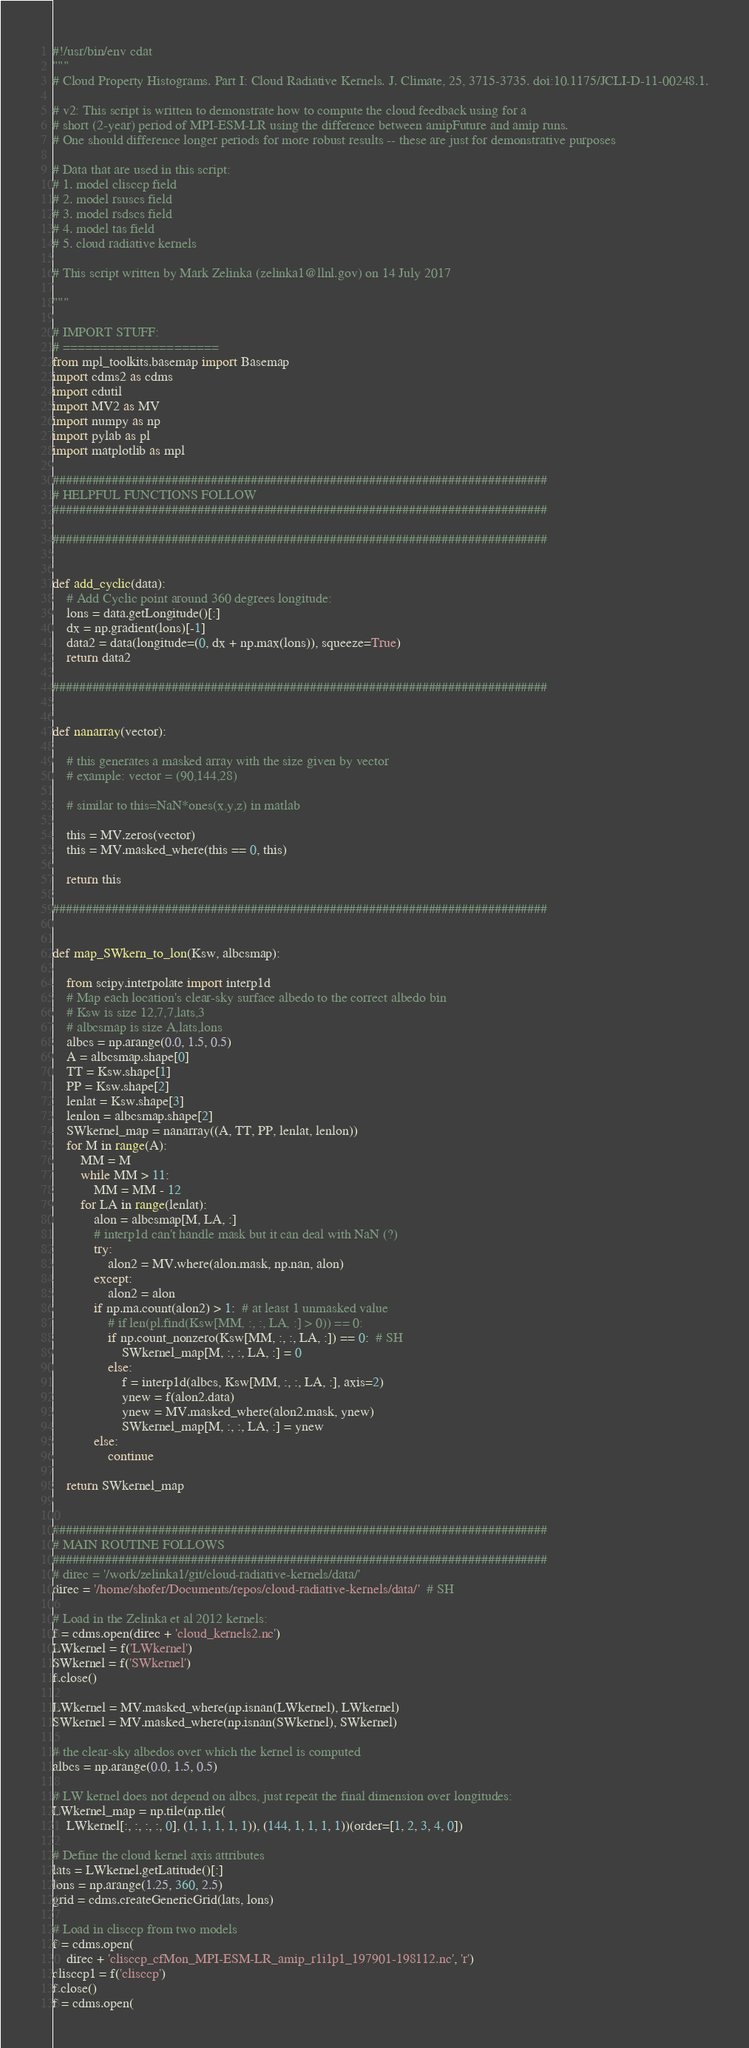<code> <loc_0><loc_0><loc_500><loc_500><_Python_>#!/usr/bin/env cdat
"""
# Cloud Property Histograms. Part I: Cloud Radiative Kernels. J. Climate, 25, 3715-3735. doi:10.1175/JCLI-D-11-00248.1.

# v2: This script is written to demonstrate how to compute the cloud feedback using for a
# short (2-year) period of MPI-ESM-LR using the difference between amipFuture and amip runs.
# One should difference longer periods for more robust results -- these are just for demonstrative purposes

# Data that are used in this script:
# 1. model clisccp field
# 2. model rsuscs field
# 3. model rsdscs field
# 4. model tas field
# 5. cloud radiative kernels

# This script written by Mark Zelinka (zelinka1@llnl.gov) on 14 July 2017

"""

# IMPORT STUFF:
# =====================
from mpl_toolkits.basemap import Basemap
import cdms2 as cdms
import cdutil
import MV2 as MV
import numpy as np
import pylab as pl
import matplotlib as mpl

###########################################################################
# HELPFUL FUNCTIONS FOLLOW
###########################################################################

###########################################################################


def add_cyclic(data):
    # Add Cyclic point around 360 degrees longitude:
    lons = data.getLongitude()[:]
    dx = np.gradient(lons)[-1]
    data2 = data(longitude=(0, dx + np.max(lons)), squeeze=True)
    return data2

###########################################################################


def nanarray(vector):

    # this generates a masked array with the size given by vector
    # example: vector = (90,144,28)

    # similar to this=NaN*ones(x,y,z) in matlab

    this = MV.zeros(vector)
    this = MV.masked_where(this == 0, this)

    return this

###########################################################################


def map_SWkern_to_lon(Ksw, albcsmap):

    from scipy.interpolate import interp1d
    # Map each location's clear-sky surface albedo to the correct albedo bin
    # Ksw is size 12,7,7,lats,3
    # albcsmap is size A,lats,lons
    albcs = np.arange(0.0, 1.5, 0.5)
    A = albcsmap.shape[0]
    TT = Ksw.shape[1]
    PP = Ksw.shape[2]
    lenlat = Ksw.shape[3]
    lenlon = albcsmap.shape[2]
    SWkernel_map = nanarray((A, TT, PP, lenlat, lenlon))
    for M in range(A):
        MM = M
        while MM > 11:
            MM = MM - 12
        for LA in range(lenlat):
            alon = albcsmap[M, LA, :]
            # interp1d can't handle mask but it can deal with NaN (?)
            try:
                alon2 = MV.where(alon.mask, np.nan, alon)
            except:
                alon2 = alon
            if np.ma.count(alon2) > 1:  # at least 1 unmasked value
                # if len(pl.find(Ksw[MM, :, :, LA, :] > 0)) == 0:
                if np.count_nonzero(Ksw[MM, :, :, LA, :]) == 0:  # SH
                    SWkernel_map[M, :, :, LA, :] = 0
                else:
                    f = interp1d(albcs, Ksw[MM, :, :, LA, :], axis=2)
                    ynew = f(alon2.data)
                    ynew = MV.masked_where(alon2.mask, ynew)
                    SWkernel_map[M, :, :, LA, :] = ynew
            else:
                continue

    return SWkernel_map


###########################################################################
# MAIN ROUTINE FOLLOWS
###########################################################################
# direc = '/work/zelinka1/git/cloud-radiative-kernels/data/'
direc = '/home/shofer/Documents/repos/cloud-radiative-kernels/data/'  # SH

# Load in the Zelinka et al 2012 kernels:
f = cdms.open(direc + 'cloud_kernels2.nc')
LWkernel = f('LWkernel')
SWkernel = f('SWkernel')
f.close()

LWkernel = MV.masked_where(np.isnan(LWkernel), LWkernel)
SWkernel = MV.masked_where(np.isnan(SWkernel), SWkernel)

# the clear-sky albedos over which the kernel is computed
albcs = np.arange(0.0, 1.5, 0.5)

# LW kernel does not depend on albcs, just repeat the final dimension over longitudes:
LWkernel_map = np.tile(np.tile(
    LWkernel[:, :, :, :, 0], (1, 1, 1, 1, 1)), (144, 1, 1, 1, 1))(order=[1, 2, 3, 4, 0])

# Define the cloud kernel axis attributes
lats = LWkernel.getLatitude()[:]
lons = np.arange(1.25, 360, 2.5)
grid = cdms.createGenericGrid(lats, lons)

# Load in clisccp from two models
f = cdms.open(
    direc + 'clisccp_cfMon_MPI-ESM-LR_amip_r1i1p1_197901-198112.nc', 'r')
clisccp1 = f('clisccp')
f.close()
f = cdms.open(</code> 